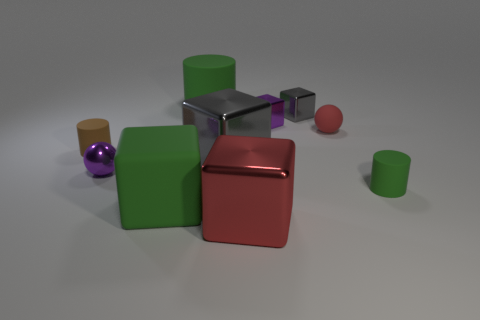Subtract all green cylinders. How many gray cubes are left? 2 Subtract all red blocks. How many blocks are left? 4 Subtract all gray metal blocks. How many blocks are left? 3 Subtract all red cubes. Subtract all brown spheres. How many cubes are left? 4 Subtract all spheres. How many objects are left? 8 Add 9 big brown rubber cylinders. How many big brown rubber cylinders exist? 9 Subtract 0 green spheres. How many objects are left? 10 Subtract all gray metallic balls. Subtract all tiny red things. How many objects are left? 9 Add 2 small rubber cylinders. How many small rubber cylinders are left? 4 